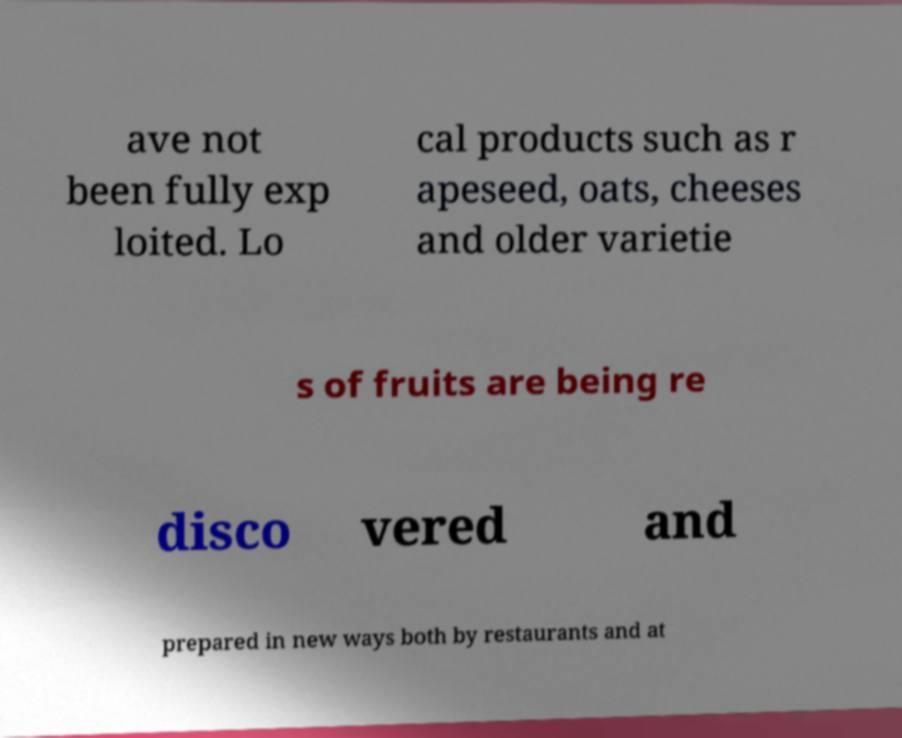Could you assist in decoding the text presented in this image and type it out clearly? ave not been fully exp loited. Lo cal products such as r apeseed, oats, cheeses and older varietie s of fruits are being re disco vered and prepared in new ways both by restaurants and at 